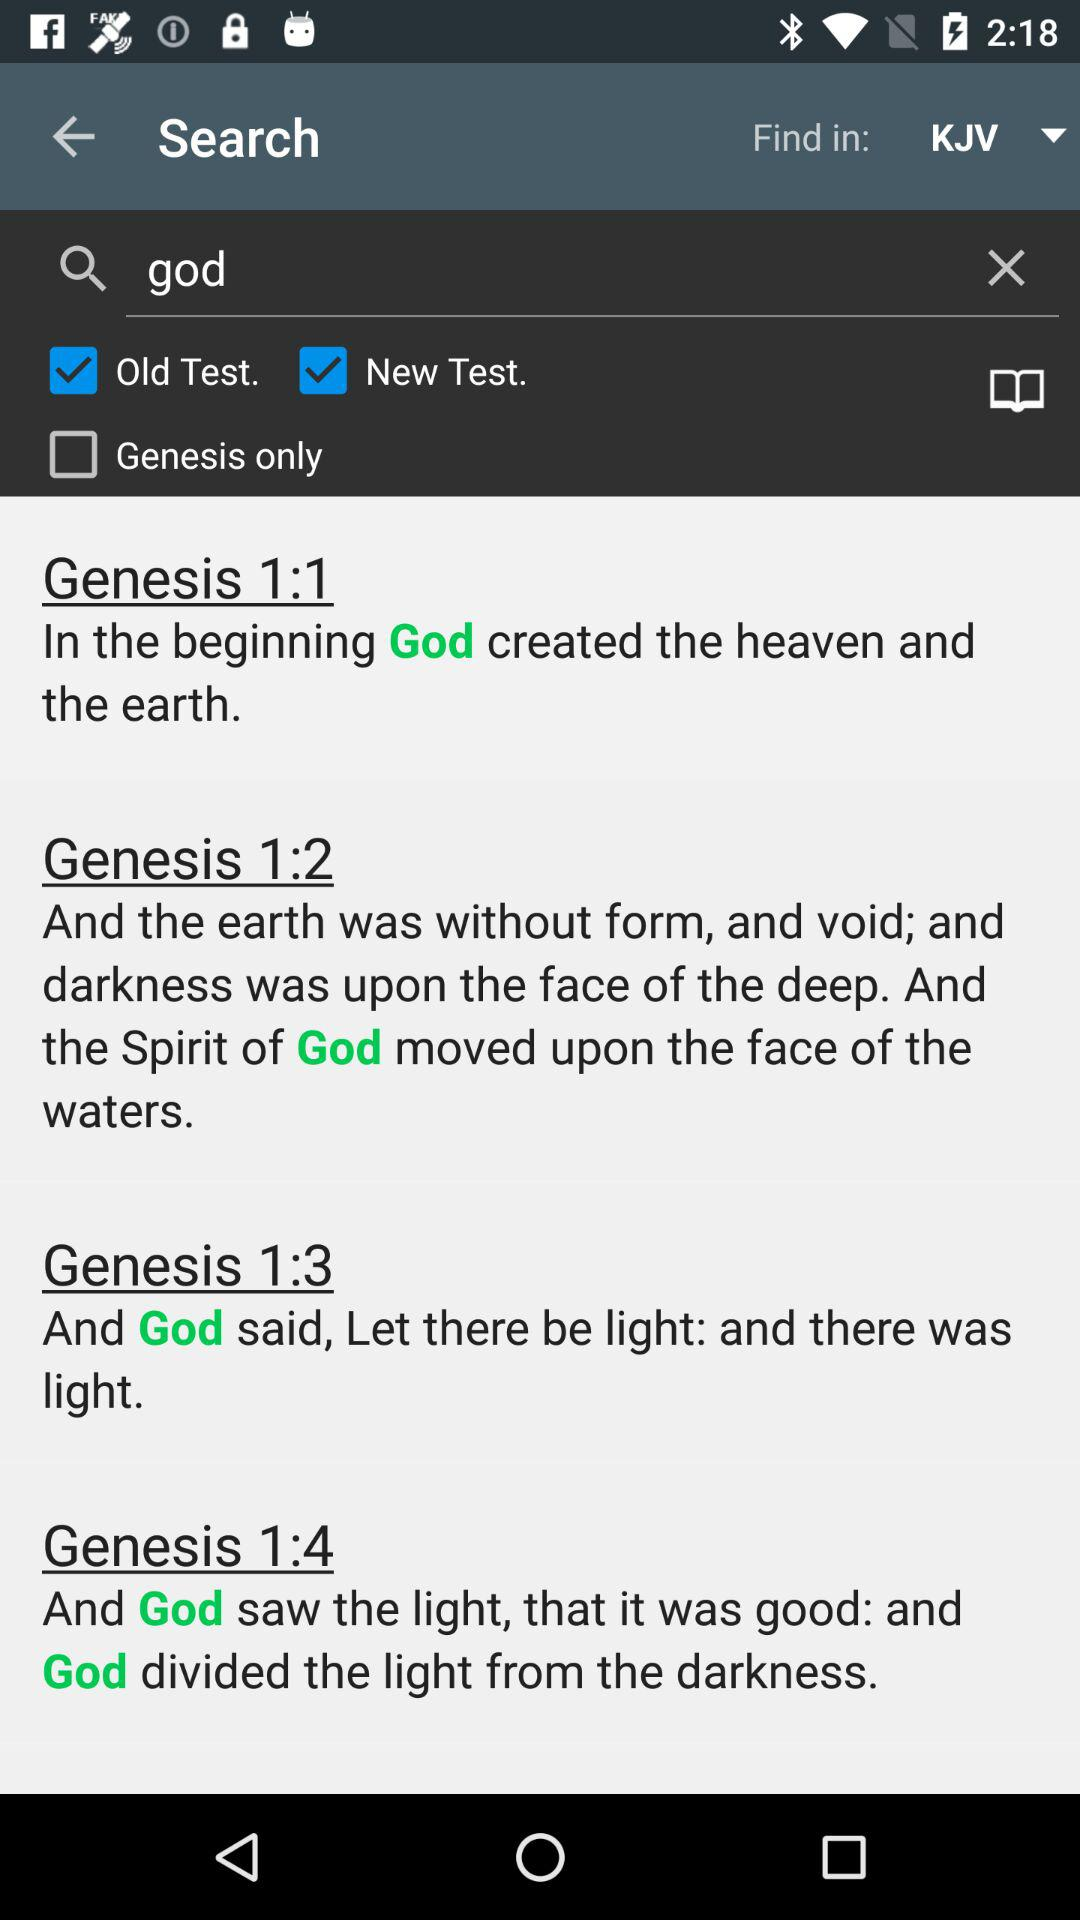How many verses are there in the selected passage?
Answer the question using a single word or phrase. 4 